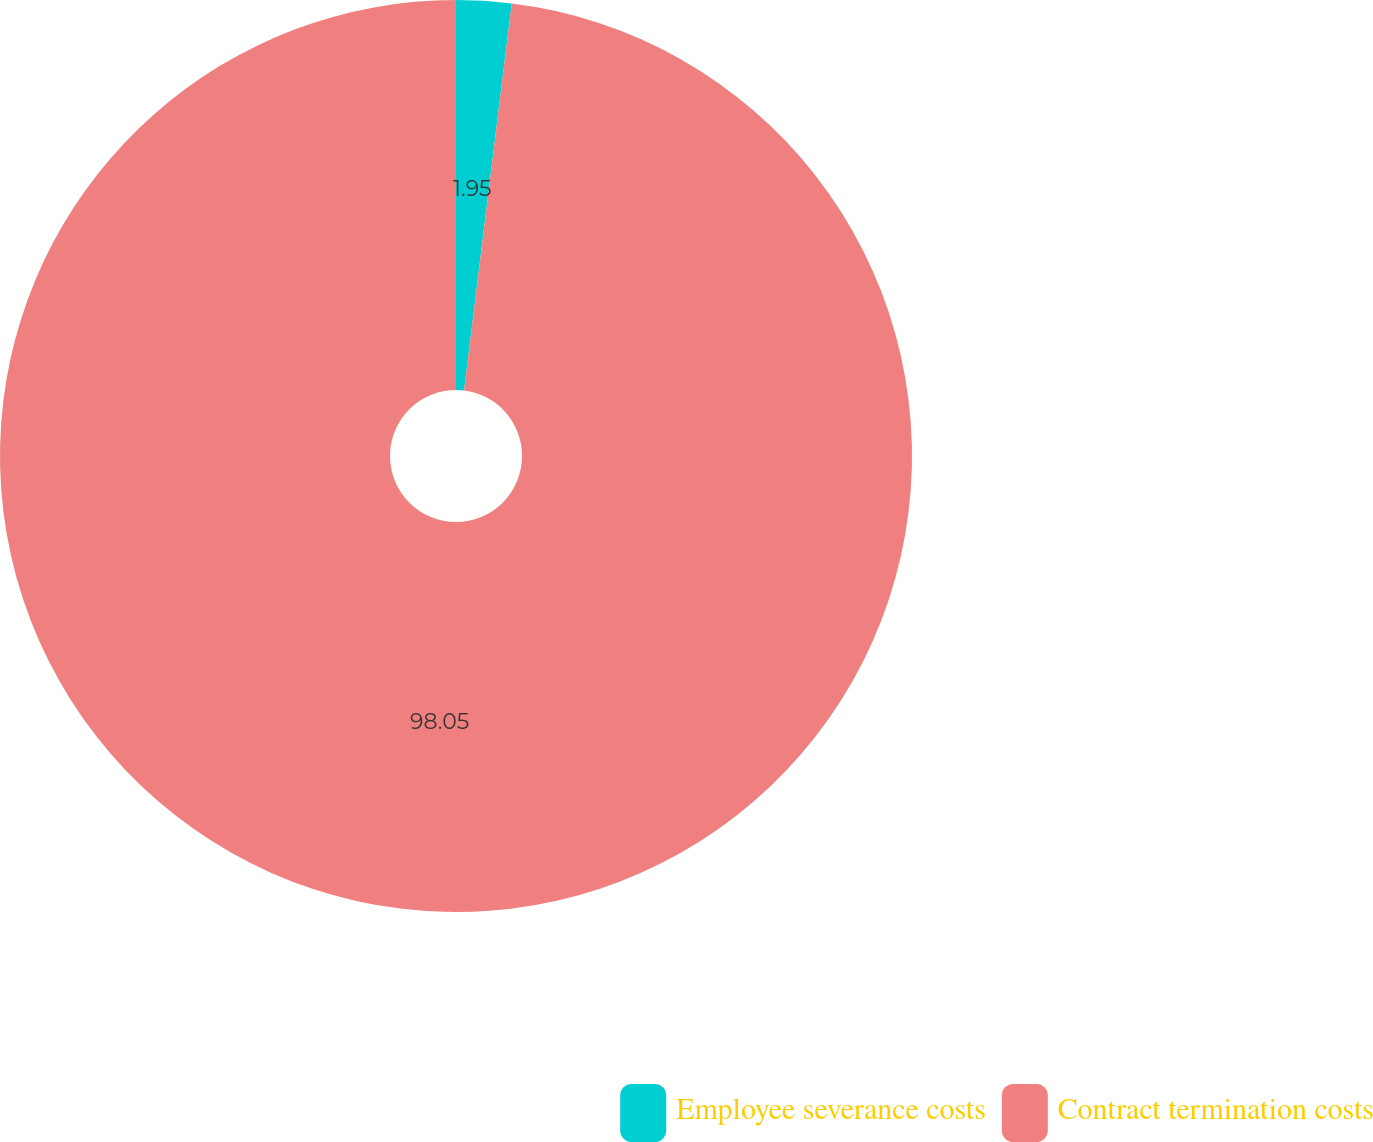Convert chart. <chart><loc_0><loc_0><loc_500><loc_500><pie_chart><fcel>Employee severance costs<fcel>Contract termination costs<nl><fcel>1.95%<fcel>98.05%<nl></chart> 